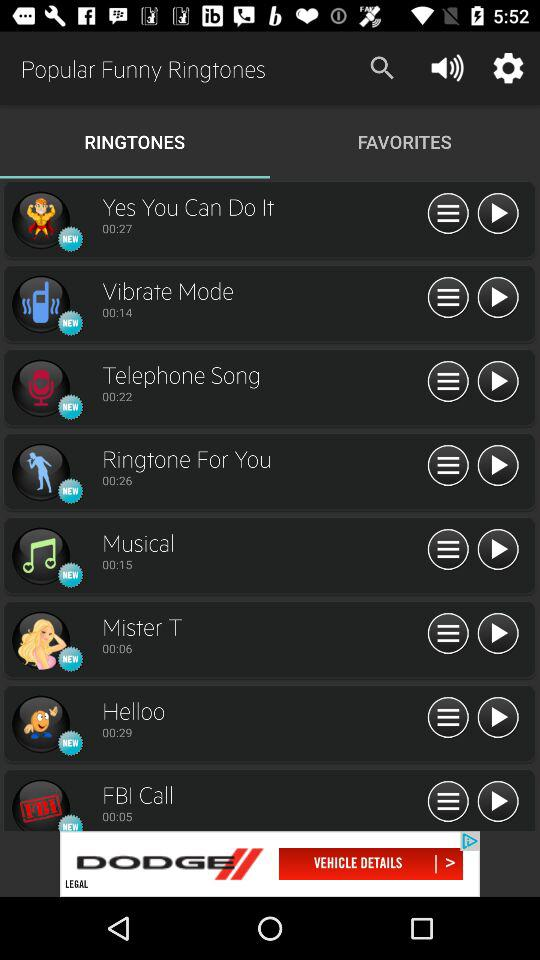Which ringtones are in "FAVORITES"?
When the provided information is insufficient, respond with <no answer>. <no answer> 